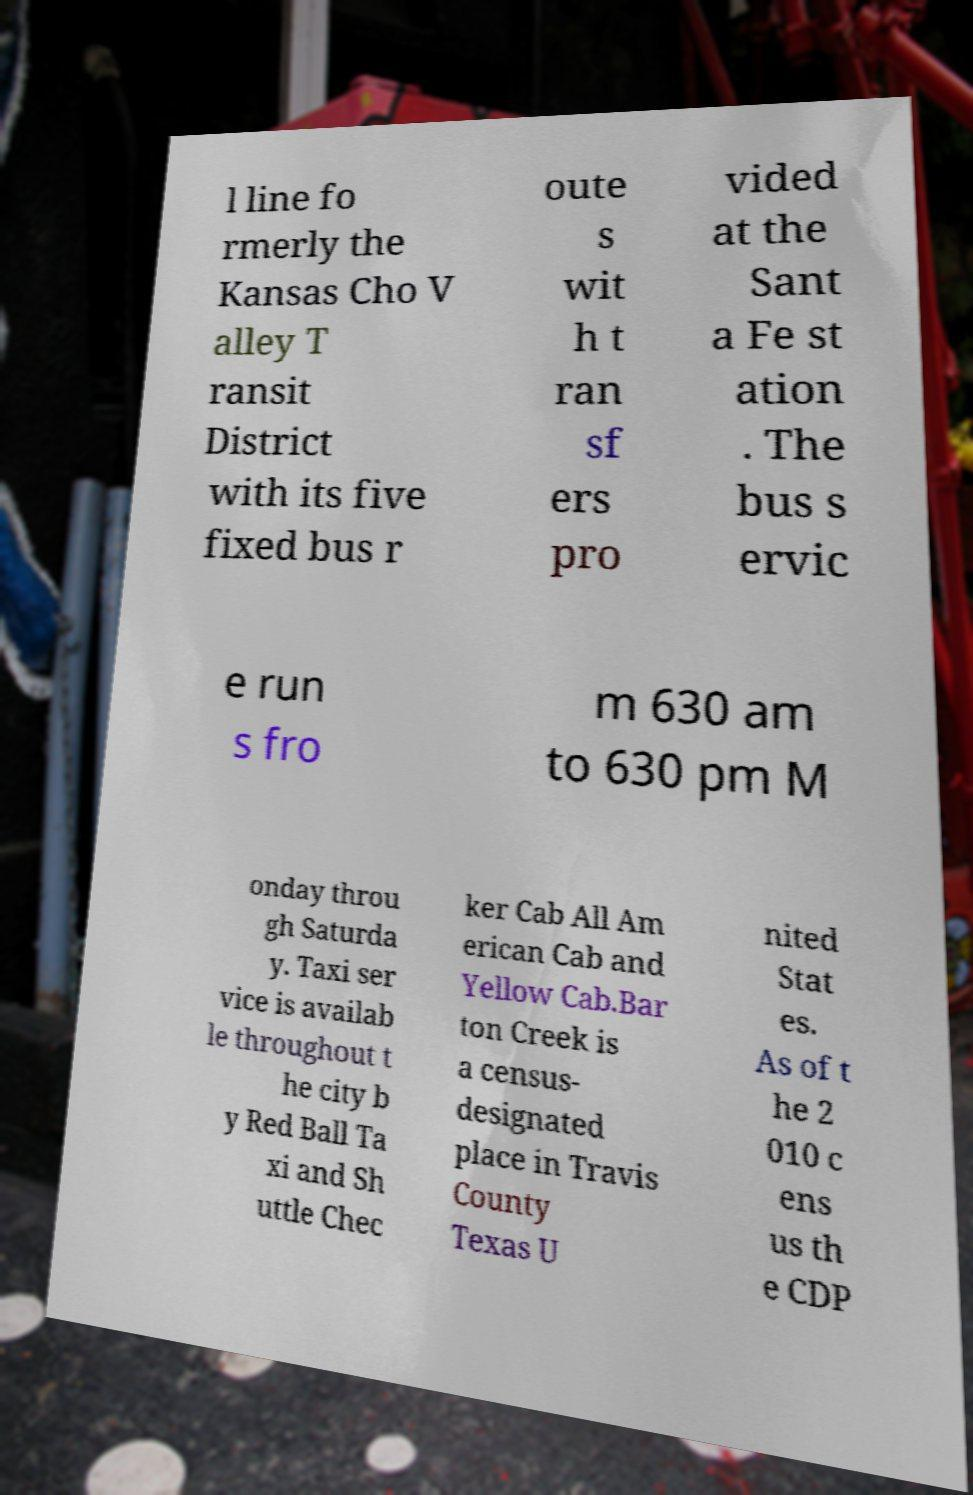Could you assist in decoding the text presented in this image and type it out clearly? l line fo rmerly the Kansas Cho V alley T ransit District with its five fixed bus r oute s wit h t ran sf ers pro vided at the Sant a Fe st ation . The bus s ervic e run s fro m 630 am to 630 pm M onday throu gh Saturda y. Taxi ser vice is availab le throughout t he city b y Red Ball Ta xi and Sh uttle Chec ker Cab All Am erican Cab and Yellow Cab.Bar ton Creek is a census- designated place in Travis County Texas U nited Stat es. As of t he 2 010 c ens us th e CDP 